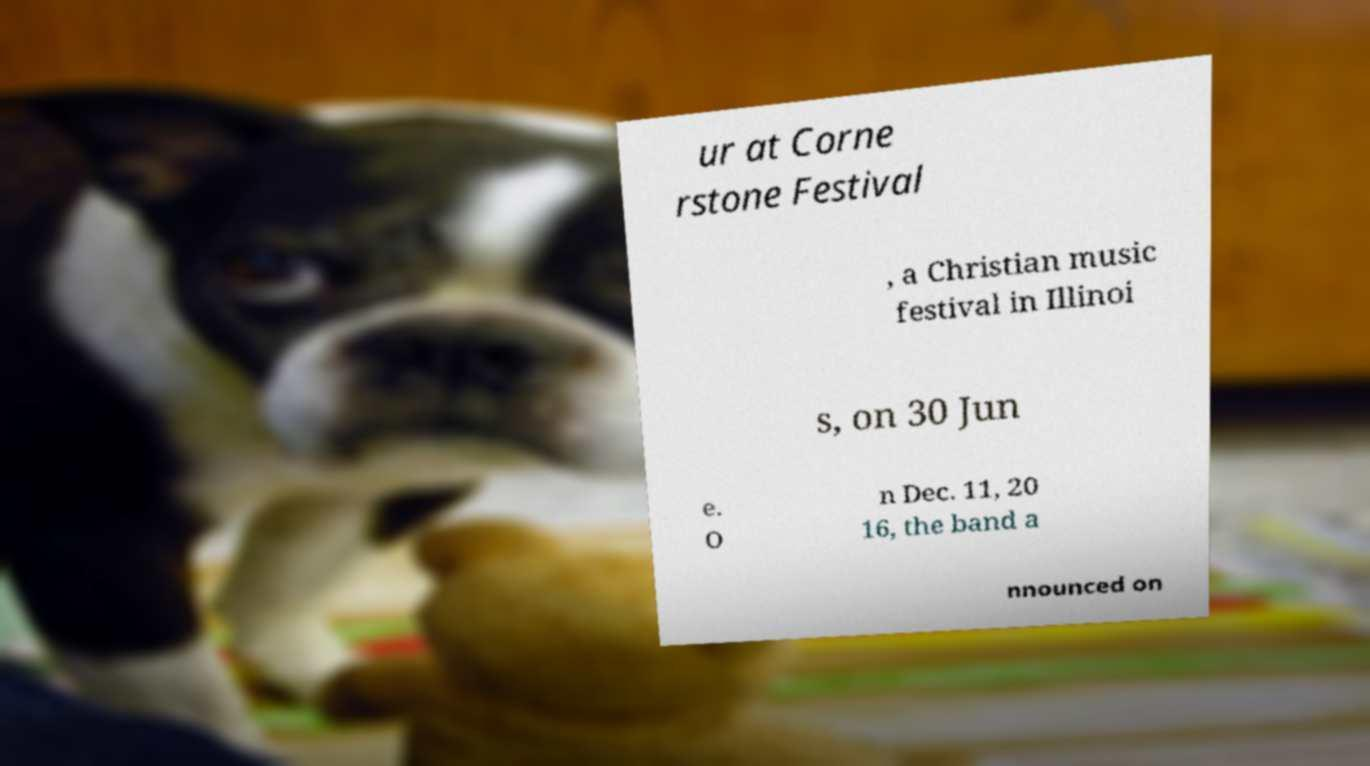I need the written content from this picture converted into text. Can you do that? ur at Corne rstone Festival , a Christian music festival in Illinoi s, on 30 Jun e. O n Dec. 11, 20 16, the band a nnounced on 